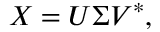<formula> <loc_0><loc_0><loc_500><loc_500>X = U \Sigma V ^ { * } ,</formula> 